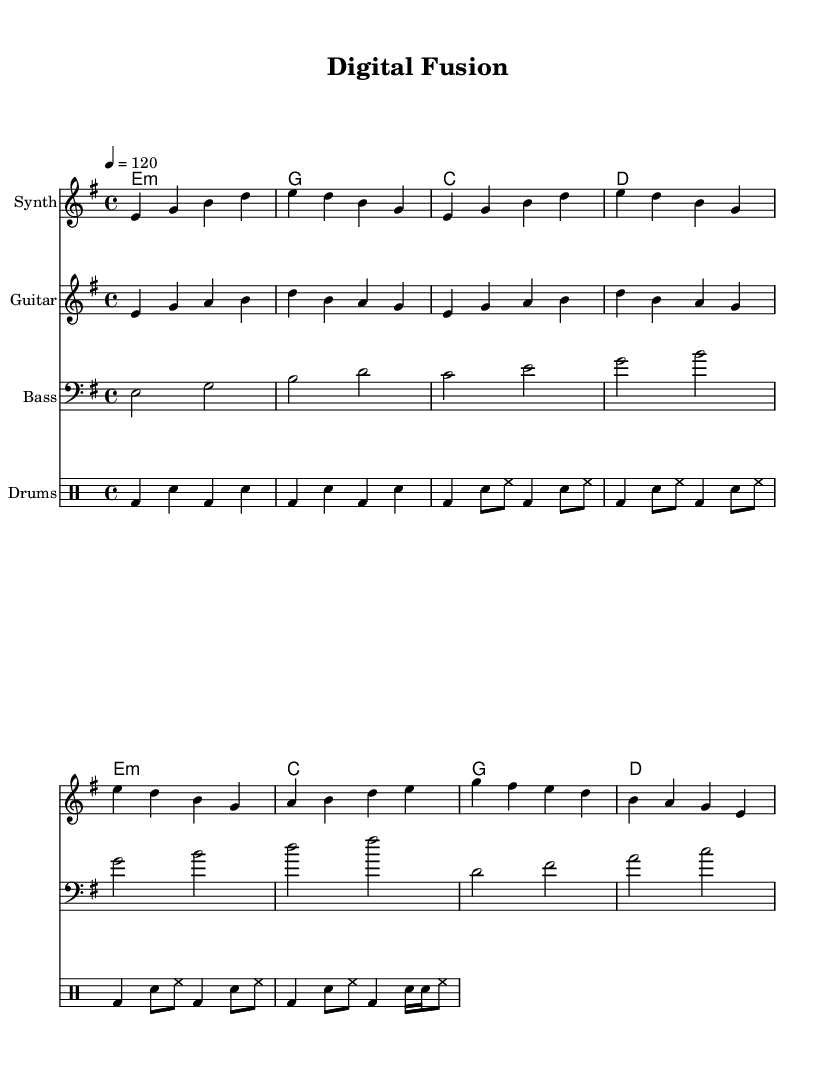What is the key signature of this music? The key signature is E minor, which contains one sharp (F#).
Answer: E minor What is the time signature of this music? The time signature is indicated at the beginning of the score, showing that it is 4/4, meaning there are four beats in a measure.
Answer: 4/4 What is the tempo marking for this piece? The tempo marking indicates the speed of the piece, which is set to a quarter note equals 120 beats per minute.
Answer: 120 How many measures does the synth intro contain? By counting the measures in the synth intro section, there are a total of 4 measures.
Answer: 4 In which section of the song does the guitar part first appear? The guitar part first appears in the verse section, as indicated by the naming of the musical sections and the corresponding notation.
Answer: Verse What instruments are featured in this piece? The score includes parts for Synth, Guitar, Bass, and Drums, as indicated by the labeled staves in the score.
Answer: Synth, Guitar, Bass, Drums What type of chords are primarily used in the guitar section? The chords used in the guitar section are primarily minor and major chords, indicated by the symbols written above the staff as chord names.
Answer: Minor and Major 